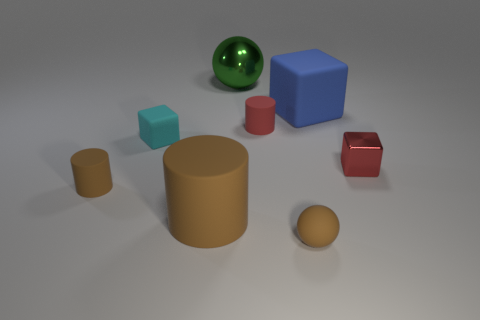Add 2 blue cylinders. How many objects exist? 10 Subtract all cylinders. How many objects are left? 5 Subtract all large blue matte things. Subtract all large gray metallic objects. How many objects are left? 7 Add 5 tiny rubber balls. How many tiny rubber balls are left? 6 Add 2 green metal balls. How many green metal balls exist? 3 Subtract 1 green balls. How many objects are left? 7 